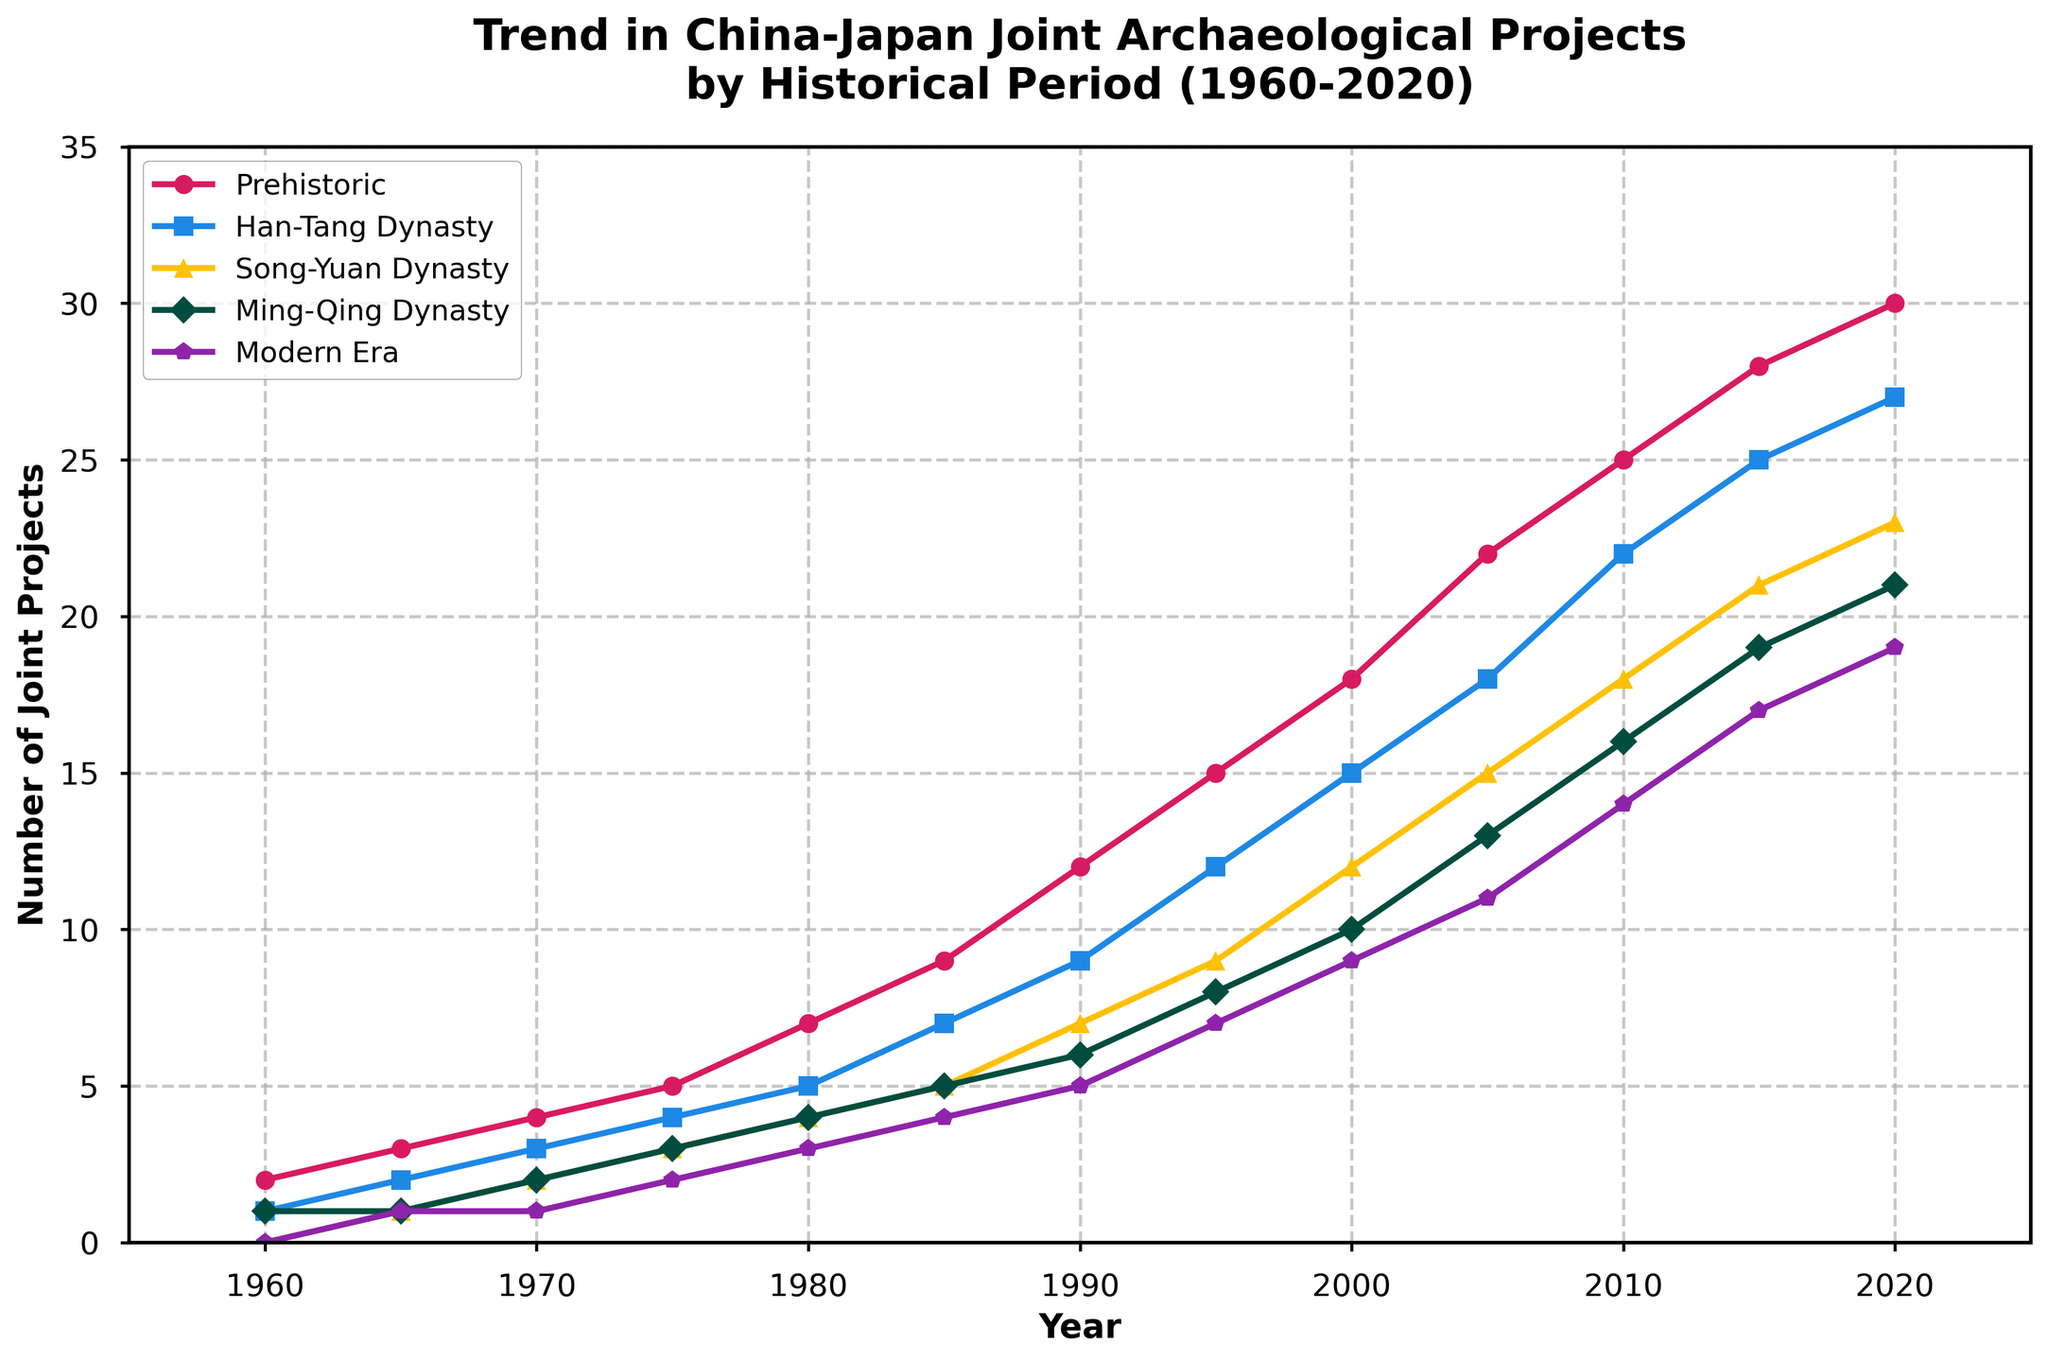What period had the highest number of joint projects in 2020? To determine the period with the highest number of joint projects in 2020, observe the endpoints of the line for each period at 2020. The "Prehistoric" period has the highest value, which is confirmed by the data point at that year.
Answer: Prehistoric How many more joint projects were there in the Ming-Qing Dynasty period in 2020 compared to 1960? Look at the number of joint projects for the Ming-Qing Dynasty period in both 2020 and 1960. In 2020, there were 21 projects, while in 1960, there was 1 project. The difference is calculated as 21 - 1.
Answer: 20 Which period experienced the smalles increase in joint projects between 1960 and 2020? Calculate the difference between the number of projects in 2020 and 1960 for each period. The "Modern Era" went from 0 to 19, which is the smallest range of increase compared to others.
Answer: Modern Era In what year did the number of joint projects for the Han-Tang Dynasty period equal the number for the Song-Yuan Dynasty period? Observe the intersection points of the lines for the Han-Tang Dynasty and Song-Yuan Dynasty periods. They intersect at 1970 where both have 3 and 3 projects respectively.
Answer: 1970 What is the total number of joint projects in 1985 across all periods? Add the number of joint projects for all periods in 1985: 9 (Prehistoric) + 7 (Han-Tang Dynasty) + 5 (Song-Yuan Dynasty) + 5 (Ming-Qing Dynasty) + 4 (Modern Era). The sum is 9 + 7 + 5 + 5 + 4.
Answer: 30 Which period shows the steepest increase in joint projects from 2000 to 2005? Evaluate the slopes of the lines between the years 2000 and 2005 for each period. The period with the steepest line will have the greatest increase. The "Prehistoric" period increases from 18 to 22, which is the steepest.
Answer: Prehistoric Compare the number of joint projects in the Modern Era at the start and end of the period 1960 to 2020. What is the ratio of the number of joint projects at the start versus the end? The number of projects in the Modern Era period in 1960 is 0 while it is 19 in 2020. The ratio is 0/19. Since it's zero at the start, the ratio indicates that there were no projects initially.
Answer: 0 Did any period other than the Prehistoric have 21 or more joint projects at any point between 1960 and 2020? Look for any points where the other periods reach or exceed 21 projects. Only the Ming-Qing Dynasty reaches 21 projects in 2020. Hence, only the Ming-Qing Dynasty meets this criterion.
Answer: Ming-Qing Dynasty What was the average number of joint projects for the Song-Yuan period from 1960 to 2020? Calculate the average by summing the number of projects in the Song-Yuan Dynasty period across all years and dividing by the number of data points: (0+1+2+3+4+5+7+9+12+15+18+21+23)/13. Sum is 120, average is 120/13.
Answer: ~9.23 